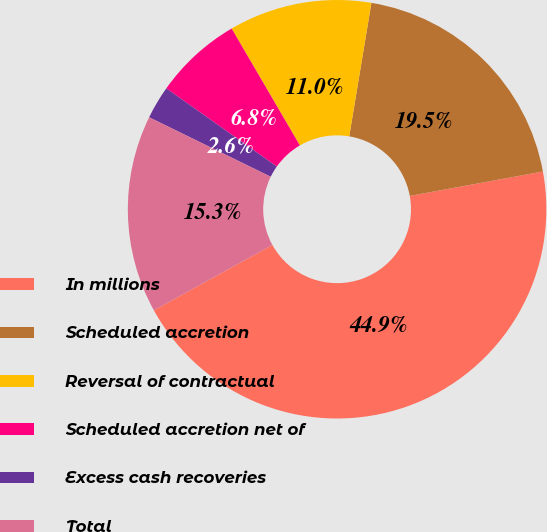Convert chart. <chart><loc_0><loc_0><loc_500><loc_500><pie_chart><fcel>In millions<fcel>Scheduled accretion<fcel>Reversal of contractual<fcel>Scheduled accretion net of<fcel>Excess cash recoveries<fcel>Total<nl><fcel>44.87%<fcel>19.49%<fcel>11.03%<fcel>6.79%<fcel>2.56%<fcel>15.26%<nl></chart> 